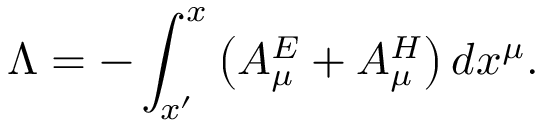<formula> <loc_0><loc_0><loc_500><loc_500>\ \Lambda = - \int _ { x ^ { \prime } } ^ { x } \left ( A _ { \mu } ^ { E } + A _ { \mu } ^ { H } \right ) d x ^ { \mu } .</formula> 